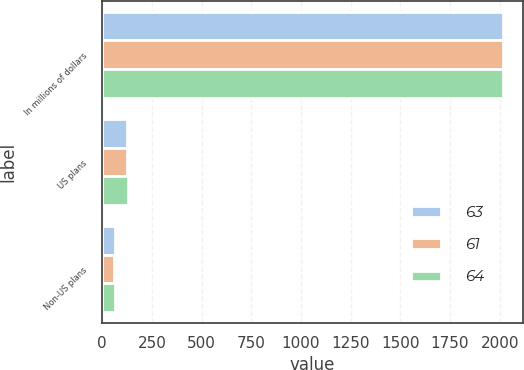Convert chart to OTSL. <chart><loc_0><loc_0><loc_500><loc_500><stacked_bar_chart><ecel><fcel>In millions of dollars<fcel>US plans<fcel>Non-US plans<nl><fcel>63<fcel>2017<fcel>127<fcel>64<nl><fcel>61<fcel>2016<fcel>127<fcel>61<nl><fcel>64<fcel>2015<fcel>128<fcel>63<nl></chart> 